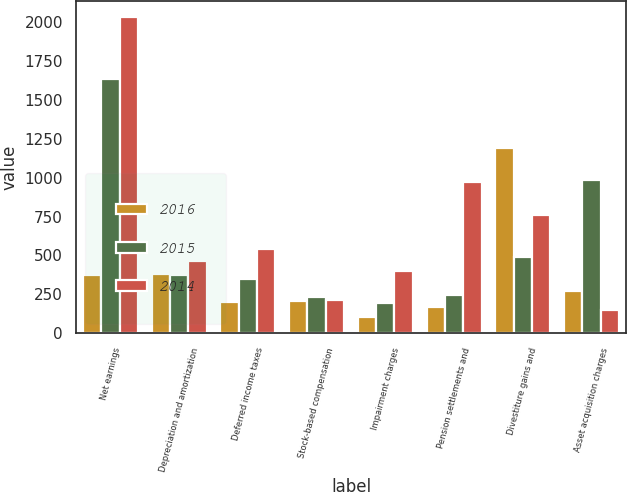Convert chart to OTSL. <chart><loc_0><loc_0><loc_500><loc_500><stacked_bar_chart><ecel><fcel>Net earnings<fcel>Depreciation and amortization<fcel>Deferred income taxes<fcel>Stock-based compensation<fcel>Impairment charges<fcel>Pension settlements and<fcel>Divestiture gains and<fcel>Asset acquisition charges<nl><fcel>2016<fcel>376<fcel>382<fcel>204<fcel>205<fcel>108<fcel>169<fcel>1187<fcel>274<nl><fcel>2015<fcel>1631<fcel>376<fcel>347<fcel>235<fcel>192<fcel>245<fcel>490<fcel>983<nl><fcel>2014<fcel>2029<fcel>467<fcel>542<fcel>213<fcel>401<fcel>971<fcel>760<fcel>148<nl></chart> 